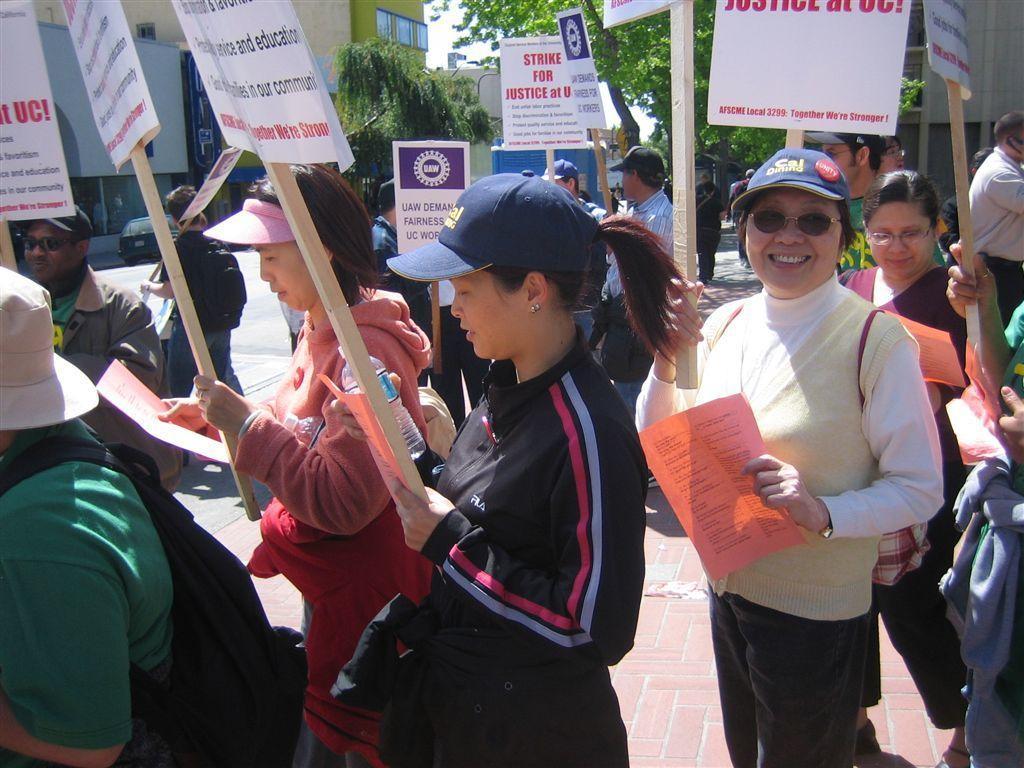Could you give a brief overview of what you see in this image? In the image we can see there are many people standing, they are wearing clothes and some of them are wearing a cap. This is a water bottle, stick, poster, floor, goggles, earring, trees, building, sky and a vehicle on the road. 